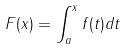<formula> <loc_0><loc_0><loc_500><loc_500>F ( x ) = \int _ { a } ^ { x } f ( t ) d t</formula> 